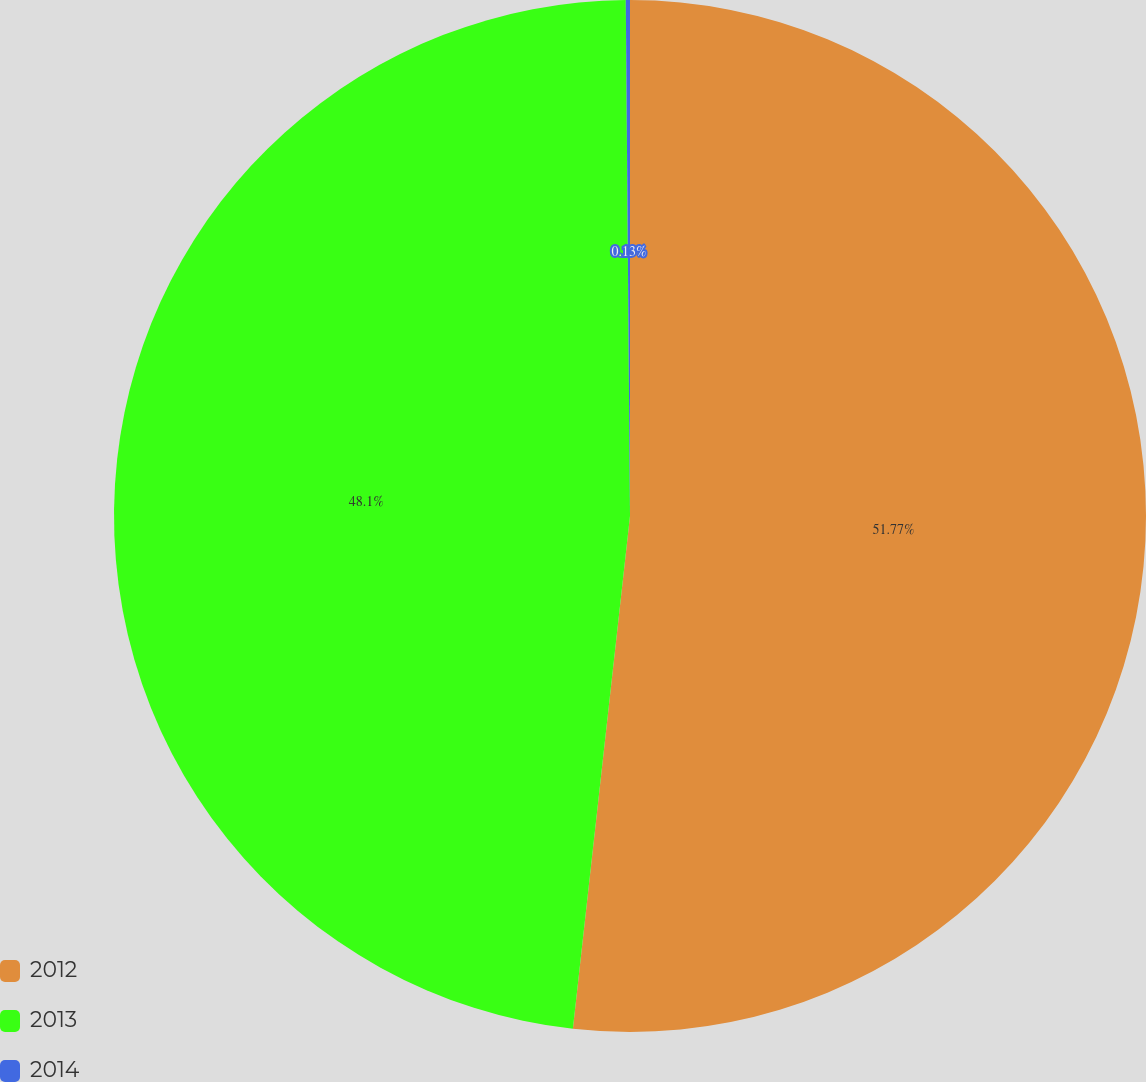Convert chart. <chart><loc_0><loc_0><loc_500><loc_500><pie_chart><fcel>2012<fcel>2013<fcel>2014<nl><fcel>51.76%<fcel>48.1%<fcel>0.13%<nl></chart> 